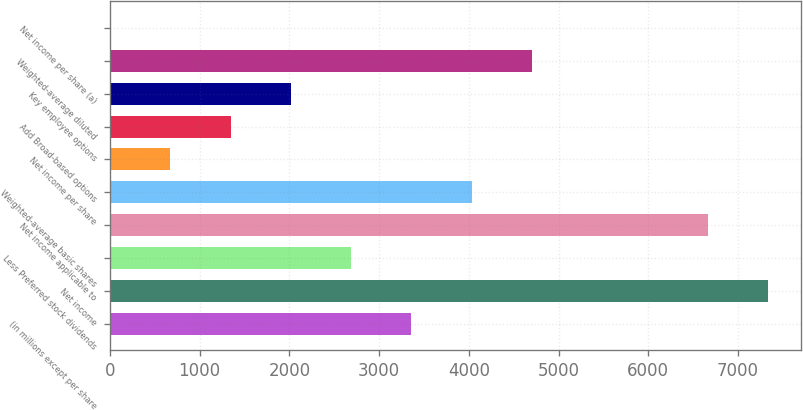<chart> <loc_0><loc_0><loc_500><loc_500><bar_chart><fcel>(in millions except per share<fcel>Net income<fcel>Less Preferred stock dividends<fcel>Net income applicable to<fcel>Weighted-average basic shares<fcel>Net income per share<fcel>Add Broad-based options<fcel>Key employee options<fcel>Weighted-average diluted<fcel>Net income per share (a)<nl><fcel>3361.14<fcel>7339.58<fcel>2689.56<fcel>6668<fcel>4032.72<fcel>674.82<fcel>1346.4<fcel>2017.98<fcel>4704.3<fcel>3.24<nl></chart> 